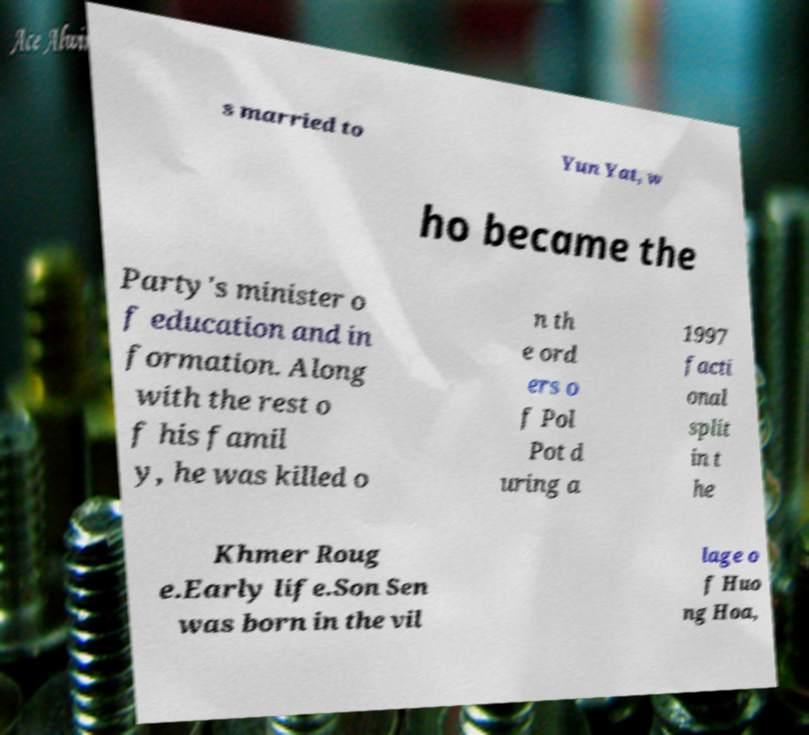Can you read and provide the text displayed in the image?This photo seems to have some interesting text. Can you extract and type it out for me? s married to Yun Yat, w ho became the Party's minister o f education and in formation. Along with the rest o f his famil y, he was killed o n th e ord ers o f Pol Pot d uring a 1997 facti onal split in t he Khmer Roug e.Early life.Son Sen was born in the vil lage o f Huo ng Hoa, 